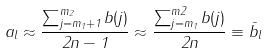Convert formula to latex. <formula><loc_0><loc_0><loc_500><loc_500>a _ { l } \approx \frac { \sum _ { j = m _ { 1 } + 1 } ^ { m _ { 2 } } b ( j ) } { 2 n - 1 } \approx \frac { \sum _ { j = m _ { 1 } } ^ { m 2 } b ( j ) } { 2 n } \equiv \bar { b } _ { l }</formula> 